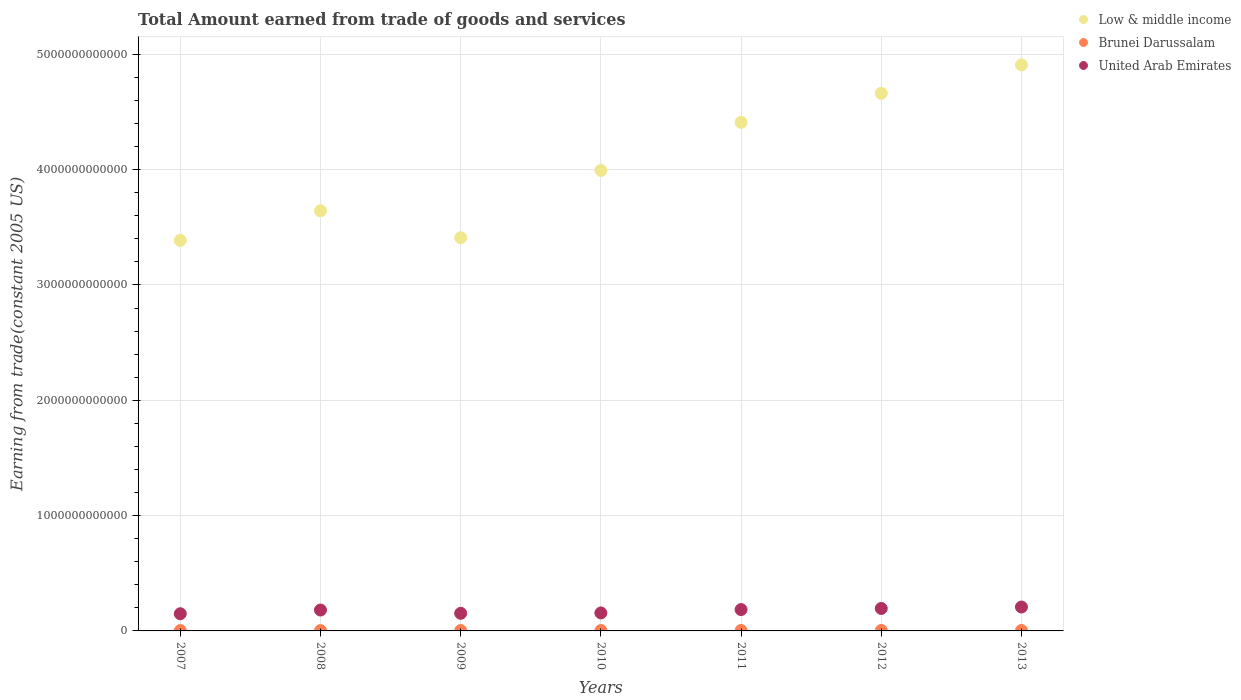How many different coloured dotlines are there?
Keep it short and to the point. 3. Is the number of dotlines equal to the number of legend labels?
Offer a terse response. Yes. What is the total amount earned by trading goods and services in United Arab Emirates in 2009?
Your answer should be very brief. 1.53e+11. Across all years, what is the maximum total amount earned by trading goods and services in United Arab Emirates?
Your response must be concise. 2.07e+11. Across all years, what is the minimum total amount earned by trading goods and services in Low & middle income?
Make the answer very short. 3.39e+12. In which year was the total amount earned by trading goods and services in United Arab Emirates maximum?
Offer a very short reply. 2013. In which year was the total amount earned by trading goods and services in Brunei Darussalam minimum?
Provide a short and direct response. 2007. What is the total total amount earned by trading goods and services in Brunei Darussalam in the graph?
Keep it short and to the point. 2.53e+1. What is the difference between the total amount earned by trading goods and services in Low & middle income in 2009 and that in 2011?
Keep it short and to the point. -1.00e+12. What is the difference between the total amount earned by trading goods and services in Brunei Darussalam in 2011 and the total amount earned by trading goods and services in United Arab Emirates in 2013?
Your answer should be compact. -2.04e+11. What is the average total amount earned by trading goods and services in Brunei Darussalam per year?
Your answer should be very brief. 3.62e+09. In the year 2008, what is the difference between the total amount earned by trading goods and services in Low & middle income and total amount earned by trading goods and services in Brunei Darussalam?
Provide a succinct answer. 3.64e+12. In how many years, is the total amount earned by trading goods and services in Brunei Darussalam greater than 800000000000 US$?
Your answer should be very brief. 0. What is the ratio of the total amount earned by trading goods and services in United Arab Emirates in 2009 to that in 2013?
Your answer should be very brief. 0.74. Is the total amount earned by trading goods and services in Brunei Darussalam in 2010 less than that in 2011?
Provide a succinct answer. Yes. What is the difference between the highest and the second highest total amount earned by trading goods and services in Low & middle income?
Keep it short and to the point. 2.47e+11. What is the difference between the highest and the lowest total amount earned by trading goods and services in United Arab Emirates?
Ensure brevity in your answer.  5.82e+1. In how many years, is the total amount earned by trading goods and services in United Arab Emirates greater than the average total amount earned by trading goods and services in United Arab Emirates taken over all years?
Give a very brief answer. 4. Is the sum of the total amount earned by trading goods and services in Low & middle income in 2007 and 2012 greater than the maximum total amount earned by trading goods and services in United Arab Emirates across all years?
Offer a terse response. Yes. Is it the case that in every year, the sum of the total amount earned by trading goods and services in Low & middle income and total amount earned by trading goods and services in Brunei Darussalam  is greater than the total amount earned by trading goods and services in United Arab Emirates?
Give a very brief answer. Yes. Is the total amount earned by trading goods and services in Low & middle income strictly greater than the total amount earned by trading goods and services in Brunei Darussalam over the years?
Your answer should be compact. Yes. Is the total amount earned by trading goods and services in Low & middle income strictly less than the total amount earned by trading goods and services in Brunei Darussalam over the years?
Your response must be concise. No. How many dotlines are there?
Your answer should be compact. 3. What is the difference between two consecutive major ticks on the Y-axis?
Offer a terse response. 1.00e+12. Does the graph contain grids?
Provide a short and direct response. Yes. Where does the legend appear in the graph?
Provide a succinct answer. Top right. How are the legend labels stacked?
Provide a succinct answer. Vertical. What is the title of the graph?
Provide a succinct answer. Total Amount earned from trade of goods and services. Does "Cyprus" appear as one of the legend labels in the graph?
Offer a terse response. No. What is the label or title of the X-axis?
Your answer should be very brief. Years. What is the label or title of the Y-axis?
Ensure brevity in your answer.  Earning from trade(constant 2005 US). What is the Earning from trade(constant 2005 US) of Low & middle income in 2007?
Provide a succinct answer. 3.39e+12. What is the Earning from trade(constant 2005 US) in Brunei Darussalam in 2007?
Ensure brevity in your answer.  3.07e+09. What is the Earning from trade(constant 2005 US) in United Arab Emirates in 2007?
Ensure brevity in your answer.  1.49e+11. What is the Earning from trade(constant 2005 US) of Low & middle income in 2008?
Provide a short and direct response. 3.64e+12. What is the Earning from trade(constant 2005 US) in Brunei Darussalam in 2008?
Your answer should be very brief. 3.40e+09. What is the Earning from trade(constant 2005 US) in United Arab Emirates in 2008?
Give a very brief answer. 1.81e+11. What is the Earning from trade(constant 2005 US) of Low & middle income in 2009?
Keep it short and to the point. 3.41e+12. What is the Earning from trade(constant 2005 US) in Brunei Darussalam in 2009?
Your answer should be very brief. 3.37e+09. What is the Earning from trade(constant 2005 US) of United Arab Emirates in 2009?
Your response must be concise. 1.53e+11. What is the Earning from trade(constant 2005 US) in Low & middle income in 2010?
Your response must be concise. 3.99e+12. What is the Earning from trade(constant 2005 US) of Brunei Darussalam in 2010?
Your answer should be compact. 3.37e+09. What is the Earning from trade(constant 2005 US) in United Arab Emirates in 2010?
Keep it short and to the point. 1.56e+11. What is the Earning from trade(constant 2005 US) in Low & middle income in 2011?
Your answer should be very brief. 4.41e+12. What is the Earning from trade(constant 2005 US) in Brunei Darussalam in 2011?
Provide a short and direct response. 3.75e+09. What is the Earning from trade(constant 2005 US) in United Arab Emirates in 2011?
Your answer should be compact. 1.85e+11. What is the Earning from trade(constant 2005 US) of Low & middle income in 2012?
Make the answer very short. 4.66e+12. What is the Earning from trade(constant 2005 US) in Brunei Darussalam in 2012?
Give a very brief answer. 4.23e+09. What is the Earning from trade(constant 2005 US) of United Arab Emirates in 2012?
Keep it short and to the point. 1.95e+11. What is the Earning from trade(constant 2005 US) in Low & middle income in 2013?
Your response must be concise. 4.91e+12. What is the Earning from trade(constant 2005 US) of Brunei Darussalam in 2013?
Ensure brevity in your answer.  4.16e+09. What is the Earning from trade(constant 2005 US) in United Arab Emirates in 2013?
Your answer should be compact. 2.07e+11. Across all years, what is the maximum Earning from trade(constant 2005 US) of Low & middle income?
Your answer should be very brief. 4.91e+12. Across all years, what is the maximum Earning from trade(constant 2005 US) of Brunei Darussalam?
Your answer should be very brief. 4.23e+09. Across all years, what is the maximum Earning from trade(constant 2005 US) of United Arab Emirates?
Provide a succinct answer. 2.07e+11. Across all years, what is the minimum Earning from trade(constant 2005 US) in Low & middle income?
Your response must be concise. 3.39e+12. Across all years, what is the minimum Earning from trade(constant 2005 US) in Brunei Darussalam?
Provide a succinct answer. 3.07e+09. Across all years, what is the minimum Earning from trade(constant 2005 US) of United Arab Emirates?
Offer a terse response. 1.49e+11. What is the total Earning from trade(constant 2005 US) of Low & middle income in the graph?
Provide a short and direct response. 2.84e+13. What is the total Earning from trade(constant 2005 US) in Brunei Darussalam in the graph?
Give a very brief answer. 2.53e+1. What is the total Earning from trade(constant 2005 US) of United Arab Emirates in the graph?
Provide a short and direct response. 1.23e+12. What is the difference between the Earning from trade(constant 2005 US) of Low & middle income in 2007 and that in 2008?
Your answer should be compact. -2.57e+11. What is the difference between the Earning from trade(constant 2005 US) of Brunei Darussalam in 2007 and that in 2008?
Your answer should be very brief. -3.36e+08. What is the difference between the Earning from trade(constant 2005 US) in United Arab Emirates in 2007 and that in 2008?
Provide a succinct answer. -3.19e+1. What is the difference between the Earning from trade(constant 2005 US) in Low & middle income in 2007 and that in 2009?
Offer a very short reply. -2.31e+1. What is the difference between the Earning from trade(constant 2005 US) in Brunei Darussalam in 2007 and that in 2009?
Your answer should be very brief. -3.09e+08. What is the difference between the Earning from trade(constant 2005 US) of United Arab Emirates in 2007 and that in 2009?
Provide a short and direct response. -3.57e+09. What is the difference between the Earning from trade(constant 2005 US) of Low & middle income in 2007 and that in 2010?
Ensure brevity in your answer.  -6.06e+11. What is the difference between the Earning from trade(constant 2005 US) of Brunei Darussalam in 2007 and that in 2010?
Make the answer very short. -3.00e+08. What is the difference between the Earning from trade(constant 2005 US) in United Arab Emirates in 2007 and that in 2010?
Offer a terse response. -6.81e+09. What is the difference between the Earning from trade(constant 2005 US) in Low & middle income in 2007 and that in 2011?
Offer a very short reply. -1.02e+12. What is the difference between the Earning from trade(constant 2005 US) of Brunei Darussalam in 2007 and that in 2011?
Your answer should be compact. -6.85e+08. What is the difference between the Earning from trade(constant 2005 US) in United Arab Emirates in 2007 and that in 2011?
Offer a terse response. -3.61e+1. What is the difference between the Earning from trade(constant 2005 US) of Low & middle income in 2007 and that in 2012?
Your answer should be very brief. -1.28e+12. What is the difference between the Earning from trade(constant 2005 US) of Brunei Darussalam in 2007 and that in 2012?
Provide a short and direct response. -1.16e+09. What is the difference between the Earning from trade(constant 2005 US) of United Arab Emirates in 2007 and that in 2012?
Provide a short and direct response. -4.56e+1. What is the difference between the Earning from trade(constant 2005 US) in Low & middle income in 2007 and that in 2013?
Your answer should be very brief. -1.52e+12. What is the difference between the Earning from trade(constant 2005 US) in Brunei Darussalam in 2007 and that in 2013?
Provide a succinct answer. -1.10e+09. What is the difference between the Earning from trade(constant 2005 US) in United Arab Emirates in 2007 and that in 2013?
Your answer should be compact. -5.82e+1. What is the difference between the Earning from trade(constant 2005 US) of Low & middle income in 2008 and that in 2009?
Give a very brief answer. 2.34e+11. What is the difference between the Earning from trade(constant 2005 US) of Brunei Darussalam in 2008 and that in 2009?
Offer a very short reply. 2.73e+07. What is the difference between the Earning from trade(constant 2005 US) in United Arab Emirates in 2008 and that in 2009?
Offer a terse response. 2.83e+1. What is the difference between the Earning from trade(constant 2005 US) of Low & middle income in 2008 and that in 2010?
Offer a terse response. -3.50e+11. What is the difference between the Earning from trade(constant 2005 US) in Brunei Darussalam in 2008 and that in 2010?
Your response must be concise. 3.63e+07. What is the difference between the Earning from trade(constant 2005 US) of United Arab Emirates in 2008 and that in 2010?
Your answer should be very brief. 2.51e+1. What is the difference between the Earning from trade(constant 2005 US) of Low & middle income in 2008 and that in 2011?
Ensure brevity in your answer.  -7.67e+11. What is the difference between the Earning from trade(constant 2005 US) in Brunei Darussalam in 2008 and that in 2011?
Give a very brief answer. -3.49e+08. What is the difference between the Earning from trade(constant 2005 US) in United Arab Emirates in 2008 and that in 2011?
Give a very brief answer. -4.16e+09. What is the difference between the Earning from trade(constant 2005 US) in Low & middle income in 2008 and that in 2012?
Provide a short and direct response. -1.02e+12. What is the difference between the Earning from trade(constant 2005 US) of Brunei Darussalam in 2008 and that in 2012?
Your answer should be compact. -8.27e+08. What is the difference between the Earning from trade(constant 2005 US) in United Arab Emirates in 2008 and that in 2012?
Keep it short and to the point. -1.37e+1. What is the difference between the Earning from trade(constant 2005 US) in Low & middle income in 2008 and that in 2013?
Provide a succinct answer. -1.27e+12. What is the difference between the Earning from trade(constant 2005 US) in Brunei Darussalam in 2008 and that in 2013?
Make the answer very short. -7.61e+08. What is the difference between the Earning from trade(constant 2005 US) in United Arab Emirates in 2008 and that in 2013?
Keep it short and to the point. -2.63e+1. What is the difference between the Earning from trade(constant 2005 US) in Low & middle income in 2009 and that in 2010?
Provide a short and direct response. -5.83e+11. What is the difference between the Earning from trade(constant 2005 US) of Brunei Darussalam in 2009 and that in 2010?
Your answer should be compact. 9.04e+06. What is the difference between the Earning from trade(constant 2005 US) in United Arab Emirates in 2009 and that in 2010?
Offer a very short reply. -3.24e+09. What is the difference between the Earning from trade(constant 2005 US) in Low & middle income in 2009 and that in 2011?
Your answer should be compact. -1.00e+12. What is the difference between the Earning from trade(constant 2005 US) of Brunei Darussalam in 2009 and that in 2011?
Your answer should be compact. -3.76e+08. What is the difference between the Earning from trade(constant 2005 US) of United Arab Emirates in 2009 and that in 2011?
Provide a succinct answer. -3.25e+1. What is the difference between the Earning from trade(constant 2005 US) in Low & middle income in 2009 and that in 2012?
Provide a succinct answer. -1.25e+12. What is the difference between the Earning from trade(constant 2005 US) in Brunei Darussalam in 2009 and that in 2012?
Offer a terse response. -8.54e+08. What is the difference between the Earning from trade(constant 2005 US) in United Arab Emirates in 2009 and that in 2012?
Your response must be concise. -4.21e+1. What is the difference between the Earning from trade(constant 2005 US) in Low & middle income in 2009 and that in 2013?
Your response must be concise. -1.50e+12. What is the difference between the Earning from trade(constant 2005 US) of Brunei Darussalam in 2009 and that in 2013?
Keep it short and to the point. -7.89e+08. What is the difference between the Earning from trade(constant 2005 US) in United Arab Emirates in 2009 and that in 2013?
Ensure brevity in your answer.  -5.47e+1. What is the difference between the Earning from trade(constant 2005 US) of Low & middle income in 2010 and that in 2011?
Offer a terse response. -4.17e+11. What is the difference between the Earning from trade(constant 2005 US) in Brunei Darussalam in 2010 and that in 2011?
Offer a terse response. -3.85e+08. What is the difference between the Earning from trade(constant 2005 US) in United Arab Emirates in 2010 and that in 2011?
Make the answer very short. -2.93e+1. What is the difference between the Earning from trade(constant 2005 US) of Low & middle income in 2010 and that in 2012?
Your answer should be compact. -6.69e+11. What is the difference between the Earning from trade(constant 2005 US) in Brunei Darussalam in 2010 and that in 2012?
Ensure brevity in your answer.  -8.63e+08. What is the difference between the Earning from trade(constant 2005 US) of United Arab Emirates in 2010 and that in 2012?
Offer a terse response. -3.88e+1. What is the difference between the Earning from trade(constant 2005 US) of Low & middle income in 2010 and that in 2013?
Offer a terse response. -9.16e+11. What is the difference between the Earning from trade(constant 2005 US) of Brunei Darussalam in 2010 and that in 2013?
Your answer should be compact. -7.98e+08. What is the difference between the Earning from trade(constant 2005 US) of United Arab Emirates in 2010 and that in 2013?
Provide a succinct answer. -5.14e+1. What is the difference between the Earning from trade(constant 2005 US) in Low & middle income in 2011 and that in 2012?
Give a very brief answer. -2.51e+11. What is the difference between the Earning from trade(constant 2005 US) in Brunei Darussalam in 2011 and that in 2012?
Your answer should be compact. -4.78e+08. What is the difference between the Earning from trade(constant 2005 US) in United Arab Emirates in 2011 and that in 2012?
Make the answer very short. -9.55e+09. What is the difference between the Earning from trade(constant 2005 US) of Low & middle income in 2011 and that in 2013?
Provide a short and direct response. -4.99e+11. What is the difference between the Earning from trade(constant 2005 US) in Brunei Darussalam in 2011 and that in 2013?
Your answer should be very brief. -4.13e+08. What is the difference between the Earning from trade(constant 2005 US) of United Arab Emirates in 2011 and that in 2013?
Make the answer very short. -2.22e+1. What is the difference between the Earning from trade(constant 2005 US) of Low & middle income in 2012 and that in 2013?
Your answer should be very brief. -2.47e+11. What is the difference between the Earning from trade(constant 2005 US) of Brunei Darussalam in 2012 and that in 2013?
Ensure brevity in your answer.  6.52e+07. What is the difference between the Earning from trade(constant 2005 US) of United Arab Emirates in 2012 and that in 2013?
Give a very brief answer. -1.26e+1. What is the difference between the Earning from trade(constant 2005 US) in Low & middle income in 2007 and the Earning from trade(constant 2005 US) in Brunei Darussalam in 2008?
Offer a very short reply. 3.38e+12. What is the difference between the Earning from trade(constant 2005 US) in Low & middle income in 2007 and the Earning from trade(constant 2005 US) in United Arab Emirates in 2008?
Make the answer very short. 3.21e+12. What is the difference between the Earning from trade(constant 2005 US) in Brunei Darussalam in 2007 and the Earning from trade(constant 2005 US) in United Arab Emirates in 2008?
Provide a succinct answer. -1.78e+11. What is the difference between the Earning from trade(constant 2005 US) in Low & middle income in 2007 and the Earning from trade(constant 2005 US) in Brunei Darussalam in 2009?
Ensure brevity in your answer.  3.38e+12. What is the difference between the Earning from trade(constant 2005 US) of Low & middle income in 2007 and the Earning from trade(constant 2005 US) of United Arab Emirates in 2009?
Provide a short and direct response. 3.23e+12. What is the difference between the Earning from trade(constant 2005 US) in Brunei Darussalam in 2007 and the Earning from trade(constant 2005 US) in United Arab Emirates in 2009?
Offer a very short reply. -1.50e+11. What is the difference between the Earning from trade(constant 2005 US) of Low & middle income in 2007 and the Earning from trade(constant 2005 US) of Brunei Darussalam in 2010?
Provide a short and direct response. 3.38e+12. What is the difference between the Earning from trade(constant 2005 US) in Low & middle income in 2007 and the Earning from trade(constant 2005 US) in United Arab Emirates in 2010?
Provide a short and direct response. 3.23e+12. What is the difference between the Earning from trade(constant 2005 US) in Brunei Darussalam in 2007 and the Earning from trade(constant 2005 US) in United Arab Emirates in 2010?
Make the answer very short. -1.53e+11. What is the difference between the Earning from trade(constant 2005 US) in Low & middle income in 2007 and the Earning from trade(constant 2005 US) in Brunei Darussalam in 2011?
Your response must be concise. 3.38e+12. What is the difference between the Earning from trade(constant 2005 US) in Low & middle income in 2007 and the Earning from trade(constant 2005 US) in United Arab Emirates in 2011?
Make the answer very short. 3.20e+12. What is the difference between the Earning from trade(constant 2005 US) in Brunei Darussalam in 2007 and the Earning from trade(constant 2005 US) in United Arab Emirates in 2011?
Keep it short and to the point. -1.82e+11. What is the difference between the Earning from trade(constant 2005 US) of Low & middle income in 2007 and the Earning from trade(constant 2005 US) of Brunei Darussalam in 2012?
Provide a short and direct response. 3.38e+12. What is the difference between the Earning from trade(constant 2005 US) of Low & middle income in 2007 and the Earning from trade(constant 2005 US) of United Arab Emirates in 2012?
Keep it short and to the point. 3.19e+12. What is the difference between the Earning from trade(constant 2005 US) of Brunei Darussalam in 2007 and the Earning from trade(constant 2005 US) of United Arab Emirates in 2012?
Your answer should be very brief. -1.92e+11. What is the difference between the Earning from trade(constant 2005 US) of Low & middle income in 2007 and the Earning from trade(constant 2005 US) of Brunei Darussalam in 2013?
Ensure brevity in your answer.  3.38e+12. What is the difference between the Earning from trade(constant 2005 US) of Low & middle income in 2007 and the Earning from trade(constant 2005 US) of United Arab Emirates in 2013?
Provide a succinct answer. 3.18e+12. What is the difference between the Earning from trade(constant 2005 US) in Brunei Darussalam in 2007 and the Earning from trade(constant 2005 US) in United Arab Emirates in 2013?
Your response must be concise. -2.04e+11. What is the difference between the Earning from trade(constant 2005 US) of Low & middle income in 2008 and the Earning from trade(constant 2005 US) of Brunei Darussalam in 2009?
Offer a terse response. 3.64e+12. What is the difference between the Earning from trade(constant 2005 US) of Low & middle income in 2008 and the Earning from trade(constant 2005 US) of United Arab Emirates in 2009?
Offer a terse response. 3.49e+12. What is the difference between the Earning from trade(constant 2005 US) in Brunei Darussalam in 2008 and the Earning from trade(constant 2005 US) in United Arab Emirates in 2009?
Your answer should be compact. -1.49e+11. What is the difference between the Earning from trade(constant 2005 US) in Low & middle income in 2008 and the Earning from trade(constant 2005 US) in Brunei Darussalam in 2010?
Keep it short and to the point. 3.64e+12. What is the difference between the Earning from trade(constant 2005 US) in Low & middle income in 2008 and the Earning from trade(constant 2005 US) in United Arab Emirates in 2010?
Your answer should be very brief. 3.49e+12. What is the difference between the Earning from trade(constant 2005 US) in Brunei Darussalam in 2008 and the Earning from trade(constant 2005 US) in United Arab Emirates in 2010?
Provide a succinct answer. -1.53e+11. What is the difference between the Earning from trade(constant 2005 US) of Low & middle income in 2008 and the Earning from trade(constant 2005 US) of Brunei Darussalam in 2011?
Offer a terse response. 3.64e+12. What is the difference between the Earning from trade(constant 2005 US) in Low & middle income in 2008 and the Earning from trade(constant 2005 US) in United Arab Emirates in 2011?
Make the answer very short. 3.46e+12. What is the difference between the Earning from trade(constant 2005 US) of Brunei Darussalam in 2008 and the Earning from trade(constant 2005 US) of United Arab Emirates in 2011?
Offer a very short reply. -1.82e+11. What is the difference between the Earning from trade(constant 2005 US) in Low & middle income in 2008 and the Earning from trade(constant 2005 US) in Brunei Darussalam in 2012?
Your answer should be very brief. 3.64e+12. What is the difference between the Earning from trade(constant 2005 US) in Low & middle income in 2008 and the Earning from trade(constant 2005 US) in United Arab Emirates in 2012?
Ensure brevity in your answer.  3.45e+12. What is the difference between the Earning from trade(constant 2005 US) of Brunei Darussalam in 2008 and the Earning from trade(constant 2005 US) of United Arab Emirates in 2012?
Your answer should be very brief. -1.91e+11. What is the difference between the Earning from trade(constant 2005 US) in Low & middle income in 2008 and the Earning from trade(constant 2005 US) in Brunei Darussalam in 2013?
Your answer should be very brief. 3.64e+12. What is the difference between the Earning from trade(constant 2005 US) of Low & middle income in 2008 and the Earning from trade(constant 2005 US) of United Arab Emirates in 2013?
Give a very brief answer. 3.44e+12. What is the difference between the Earning from trade(constant 2005 US) of Brunei Darussalam in 2008 and the Earning from trade(constant 2005 US) of United Arab Emirates in 2013?
Your response must be concise. -2.04e+11. What is the difference between the Earning from trade(constant 2005 US) of Low & middle income in 2009 and the Earning from trade(constant 2005 US) of Brunei Darussalam in 2010?
Provide a short and direct response. 3.41e+12. What is the difference between the Earning from trade(constant 2005 US) in Low & middle income in 2009 and the Earning from trade(constant 2005 US) in United Arab Emirates in 2010?
Keep it short and to the point. 3.25e+12. What is the difference between the Earning from trade(constant 2005 US) of Brunei Darussalam in 2009 and the Earning from trade(constant 2005 US) of United Arab Emirates in 2010?
Offer a very short reply. -1.53e+11. What is the difference between the Earning from trade(constant 2005 US) of Low & middle income in 2009 and the Earning from trade(constant 2005 US) of Brunei Darussalam in 2011?
Your response must be concise. 3.41e+12. What is the difference between the Earning from trade(constant 2005 US) of Low & middle income in 2009 and the Earning from trade(constant 2005 US) of United Arab Emirates in 2011?
Your answer should be compact. 3.22e+12. What is the difference between the Earning from trade(constant 2005 US) of Brunei Darussalam in 2009 and the Earning from trade(constant 2005 US) of United Arab Emirates in 2011?
Offer a terse response. -1.82e+11. What is the difference between the Earning from trade(constant 2005 US) of Low & middle income in 2009 and the Earning from trade(constant 2005 US) of Brunei Darussalam in 2012?
Provide a succinct answer. 3.41e+12. What is the difference between the Earning from trade(constant 2005 US) in Low & middle income in 2009 and the Earning from trade(constant 2005 US) in United Arab Emirates in 2012?
Offer a terse response. 3.22e+12. What is the difference between the Earning from trade(constant 2005 US) in Brunei Darussalam in 2009 and the Earning from trade(constant 2005 US) in United Arab Emirates in 2012?
Your answer should be very brief. -1.91e+11. What is the difference between the Earning from trade(constant 2005 US) of Low & middle income in 2009 and the Earning from trade(constant 2005 US) of Brunei Darussalam in 2013?
Your answer should be very brief. 3.41e+12. What is the difference between the Earning from trade(constant 2005 US) of Low & middle income in 2009 and the Earning from trade(constant 2005 US) of United Arab Emirates in 2013?
Give a very brief answer. 3.20e+12. What is the difference between the Earning from trade(constant 2005 US) of Brunei Darussalam in 2009 and the Earning from trade(constant 2005 US) of United Arab Emirates in 2013?
Make the answer very short. -2.04e+11. What is the difference between the Earning from trade(constant 2005 US) of Low & middle income in 2010 and the Earning from trade(constant 2005 US) of Brunei Darussalam in 2011?
Your answer should be very brief. 3.99e+12. What is the difference between the Earning from trade(constant 2005 US) of Low & middle income in 2010 and the Earning from trade(constant 2005 US) of United Arab Emirates in 2011?
Give a very brief answer. 3.81e+12. What is the difference between the Earning from trade(constant 2005 US) of Brunei Darussalam in 2010 and the Earning from trade(constant 2005 US) of United Arab Emirates in 2011?
Your answer should be very brief. -1.82e+11. What is the difference between the Earning from trade(constant 2005 US) in Low & middle income in 2010 and the Earning from trade(constant 2005 US) in Brunei Darussalam in 2012?
Your answer should be compact. 3.99e+12. What is the difference between the Earning from trade(constant 2005 US) of Low & middle income in 2010 and the Earning from trade(constant 2005 US) of United Arab Emirates in 2012?
Provide a short and direct response. 3.80e+12. What is the difference between the Earning from trade(constant 2005 US) in Brunei Darussalam in 2010 and the Earning from trade(constant 2005 US) in United Arab Emirates in 2012?
Your answer should be very brief. -1.91e+11. What is the difference between the Earning from trade(constant 2005 US) of Low & middle income in 2010 and the Earning from trade(constant 2005 US) of Brunei Darussalam in 2013?
Your answer should be compact. 3.99e+12. What is the difference between the Earning from trade(constant 2005 US) in Low & middle income in 2010 and the Earning from trade(constant 2005 US) in United Arab Emirates in 2013?
Ensure brevity in your answer.  3.79e+12. What is the difference between the Earning from trade(constant 2005 US) of Brunei Darussalam in 2010 and the Earning from trade(constant 2005 US) of United Arab Emirates in 2013?
Ensure brevity in your answer.  -2.04e+11. What is the difference between the Earning from trade(constant 2005 US) in Low & middle income in 2011 and the Earning from trade(constant 2005 US) in Brunei Darussalam in 2012?
Your answer should be compact. 4.41e+12. What is the difference between the Earning from trade(constant 2005 US) of Low & middle income in 2011 and the Earning from trade(constant 2005 US) of United Arab Emirates in 2012?
Provide a short and direct response. 4.22e+12. What is the difference between the Earning from trade(constant 2005 US) of Brunei Darussalam in 2011 and the Earning from trade(constant 2005 US) of United Arab Emirates in 2012?
Your answer should be compact. -1.91e+11. What is the difference between the Earning from trade(constant 2005 US) of Low & middle income in 2011 and the Earning from trade(constant 2005 US) of Brunei Darussalam in 2013?
Provide a succinct answer. 4.41e+12. What is the difference between the Earning from trade(constant 2005 US) in Low & middle income in 2011 and the Earning from trade(constant 2005 US) in United Arab Emirates in 2013?
Keep it short and to the point. 4.20e+12. What is the difference between the Earning from trade(constant 2005 US) in Brunei Darussalam in 2011 and the Earning from trade(constant 2005 US) in United Arab Emirates in 2013?
Offer a very short reply. -2.04e+11. What is the difference between the Earning from trade(constant 2005 US) in Low & middle income in 2012 and the Earning from trade(constant 2005 US) in Brunei Darussalam in 2013?
Make the answer very short. 4.66e+12. What is the difference between the Earning from trade(constant 2005 US) of Low & middle income in 2012 and the Earning from trade(constant 2005 US) of United Arab Emirates in 2013?
Ensure brevity in your answer.  4.45e+12. What is the difference between the Earning from trade(constant 2005 US) of Brunei Darussalam in 2012 and the Earning from trade(constant 2005 US) of United Arab Emirates in 2013?
Ensure brevity in your answer.  -2.03e+11. What is the average Earning from trade(constant 2005 US) in Low & middle income per year?
Make the answer very short. 4.06e+12. What is the average Earning from trade(constant 2005 US) of Brunei Darussalam per year?
Offer a terse response. 3.62e+09. What is the average Earning from trade(constant 2005 US) of United Arab Emirates per year?
Offer a very short reply. 1.75e+11. In the year 2007, what is the difference between the Earning from trade(constant 2005 US) of Low & middle income and Earning from trade(constant 2005 US) of Brunei Darussalam?
Ensure brevity in your answer.  3.38e+12. In the year 2007, what is the difference between the Earning from trade(constant 2005 US) in Low & middle income and Earning from trade(constant 2005 US) in United Arab Emirates?
Offer a terse response. 3.24e+12. In the year 2007, what is the difference between the Earning from trade(constant 2005 US) of Brunei Darussalam and Earning from trade(constant 2005 US) of United Arab Emirates?
Provide a short and direct response. -1.46e+11. In the year 2008, what is the difference between the Earning from trade(constant 2005 US) in Low & middle income and Earning from trade(constant 2005 US) in Brunei Darussalam?
Provide a short and direct response. 3.64e+12. In the year 2008, what is the difference between the Earning from trade(constant 2005 US) of Low & middle income and Earning from trade(constant 2005 US) of United Arab Emirates?
Make the answer very short. 3.46e+12. In the year 2008, what is the difference between the Earning from trade(constant 2005 US) of Brunei Darussalam and Earning from trade(constant 2005 US) of United Arab Emirates?
Your answer should be very brief. -1.78e+11. In the year 2009, what is the difference between the Earning from trade(constant 2005 US) of Low & middle income and Earning from trade(constant 2005 US) of Brunei Darussalam?
Your response must be concise. 3.41e+12. In the year 2009, what is the difference between the Earning from trade(constant 2005 US) of Low & middle income and Earning from trade(constant 2005 US) of United Arab Emirates?
Ensure brevity in your answer.  3.26e+12. In the year 2009, what is the difference between the Earning from trade(constant 2005 US) of Brunei Darussalam and Earning from trade(constant 2005 US) of United Arab Emirates?
Offer a terse response. -1.49e+11. In the year 2010, what is the difference between the Earning from trade(constant 2005 US) in Low & middle income and Earning from trade(constant 2005 US) in Brunei Darussalam?
Give a very brief answer. 3.99e+12. In the year 2010, what is the difference between the Earning from trade(constant 2005 US) in Low & middle income and Earning from trade(constant 2005 US) in United Arab Emirates?
Provide a succinct answer. 3.84e+12. In the year 2010, what is the difference between the Earning from trade(constant 2005 US) in Brunei Darussalam and Earning from trade(constant 2005 US) in United Arab Emirates?
Give a very brief answer. -1.53e+11. In the year 2011, what is the difference between the Earning from trade(constant 2005 US) in Low & middle income and Earning from trade(constant 2005 US) in Brunei Darussalam?
Keep it short and to the point. 4.41e+12. In the year 2011, what is the difference between the Earning from trade(constant 2005 US) of Low & middle income and Earning from trade(constant 2005 US) of United Arab Emirates?
Give a very brief answer. 4.23e+12. In the year 2011, what is the difference between the Earning from trade(constant 2005 US) in Brunei Darussalam and Earning from trade(constant 2005 US) in United Arab Emirates?
Keep it short and to the point. -1.82e+11. In the year 2012, what is the difference between the Earning from trade(constant 2005 US) of Low & middle income and Earning from trade(constant 2005 US) of Brunei Darussalam?
Give a very brief answer. 4.66e+12. In the year 2012, what is the difference between the Earning from trade(constant 2005 US) in Low & middle income and Earning from trade(constant 2005 US) in United Arab Emirates?
Make the answer very short. 4.47e+12. In the year 2012, what is the difference between the Earning from trade(constant 2005 US) of Brunei Darussalam and Earning from trade(constant 2005 US) of United Arab Emirates?
Offer a very short reply. -1.91e+11. In the year 2013, what is the difference between the Earning from trade(constant 2005 US) of Low & middle income and Earning from trade(constant 2005 US) of Brunei Darussalam?
Give a very brief answer. 4.90e+12. In the year 2013, what is the difference between the Earning from trade(constant 2005 US) of Low & middle income and Earning from trade(constant 2005 US) of United Arab Emirates?
Make the answer very short. 4.70e+12. In the year 2013, what is the difference between the Earning from trade(constant 2005 US) in Brunei Darussalam and Earning from trade(constant 2005 US) in United Arab Emirates?
Offer a very short reply. -2.03e+11. What is the ratio of the Earning from trade(constant 2005 US) in Low & middle income in 2007 to that in 2008?
Your response must be concise. 0.93. What is the ratio of the Earning from trade(constant 2005 US) of Brunei Darussalam in 2007 to that in 2008?
Your answer should be very brief. 0.9. What is the ratio of the Earning from trade(constant 2005 US) of United Arab Emirates in 2007 to that in 2008?
Provide a short and direct response. 0.82. What is the ratio of the Earning from trade(constant 2005 US) of Low & middle income in 2007 to that in 2009?
Ensure brevity in your answer.  0.99. What is the ratio of the Earning from trade(constant 2005 US) in Brunei Darussalam in 2007 to that in 2009?
Provide a short and direct response. 0.91. What is the ratio of the Earning from trade(constant 2005 US) of United Arab Emirates in 2007 to that in 2009?
Provide a short and direct response. 0.98. What is the ratio of the Earning from trade(constant 2005 US) of Low & middle income in 2007 to that in 2010?
Your answer should be very brief. 0.85. What is the ratio of the Earning from trade(constant 2005 US) of Brunei Darussalam in 2007 to that in 2010?
Provide a succinct answer. 0.91. What is the ratio of the Earning from trade(constant 2005 US) of United Arab Emirates in 2007 to that in 2010?
Offer a terse response. 0.96. What is the ratio of the Earning from trade(constant 2005 US) of Low & middle income in 2007 to that in 2011?
Your answer should be very brief. 0.77. What is the ratio of the Earning from trade(constant 2005 US) of Brunei Darussalam in 2007 to that in 2011?
Offer a terse response. 0.82. What is the ratio of the Earning from trade(constant 2005 US) of United Arab Emirates in 2007 to that in 2011?
Make the answer very short. 0.81. What is the ratio of the Earning from trade(constant 2005 US) in Low & middle income in 2007 to that in 2012?
Ensure brevity in your answer.  0.73. What is the ratio of the Earning from trade(constant 2005 US) in Brunei Darussalam in 2007 to that in 2012?
Give a very brief answer. 0.72. What is the ratio of the Earning from trade(constant 2005 US) of United Arab Emirates in 2007 to that in 2012?
Give a very brief answer. 0.77. What is the ratio of the Earning from trade(constant 2005 US) in Low & middle income in 2007 to that in 2013?
Offer a terse response. 0.69. What is the ratio of the Earning from trade(constant 2005 US) of Brunei Darussalam in 2007 to that in 2013?
Your response must be concise. 0.74. What is the ratio of the Earning from trade(constant 2005 US) in United Arab Emirates in 2007 to that in 2013?
Your response must be concise. 0.72. What is the ratio of the Earning from trade(constant 2005 US) in Low & middle income in 2008 to that in 2009?
Your response must be concise. 1.07. What is the ratio of the Earning from trade(constant 2005 US) in Brunei Darussalam in 2008 to that in 2009?
Offer a terse response. 1.01. What is the ratio of the Earning from trade(constant 2005 US) of United Arab Emirates in 2008 to that in 2009?
Make the answer very short. 1.19. What is the ratio of the Earning from trade(constant 2005 US) of Low & middle income in 2008 to that in 2010?
Keep it short and to the point. 0.91. What is the ratio of the Earning from trade(constant 2005 US) of Brunei Darussalam in 2008 to that in 2010?
Your answer should be compact. 1.01. What is the ratio of the Earning from trade(constant 2005 US) of United Arab Emirates in 2008 to that in 2010?
Offer a terse response. 1.16. What is the ratio of the Earning from trade(constant 2005 US) of Low & middle income in 2008 to that in 2011?
Your answer should be compact. 0.83. What is the ratio of the Earning from trade(constant 2005 US) in Brunei Darussalam in 2008 to that in 2011?
Keep it short and to the point. 0.91. What is the ratio of the Earning from trade(constant 2005 US) in United Arab Emirates in 2008 to that in 2011?
Keep it short and to the point. 0.98. What is the ratio of the Earning from trade(constant 2005 US) of Low & middle income in 2008 to that in 2012?
Provide a succinct answer. 0.78. What is the ratio of the Earning from trade(constant 2005 US) in Brunei Darussalam in 2008 to that in 2012?
Provide a short and direct response. 0.8. What is the ratio of the Earning from trade(constant 2005 US) of United Arab Emirates in 2008 to that in 2012?
Your response must be concise. 0.93. What is the ratio of the Earning from trade(constant 2005 US) in Low & middle income in 2008 to that in 2013?
Your response must be concise. 0.74. What is the ratio of the Earning from trade(constant 2005 US) in Brunei Darussalam in 2008 to that in 2013?
Make the answer very short. 0.82. What is the ratio of the Earning from trade(constant 2005 US) in United Arab Emirates in 2008 to that in 2013?
Ensure brevity in your answer.  0.87. What is the ratio of the Earning from trade(constant 2005 US) of Low & middle income in 2009 to that in 2010?
Provide a short and direct response. 0.85. What is the ratio of the Earning from trade(constant 2005 US) of Brunei Darussalam in 2009 to that in 2010?
Give a very brief answer. 1. What is the ratio of the Earning from trade(constant 2005 US) of United Arab Emirates in 2009 to that in 2010?
Ensure brevity in your answer.  0.98. What is the ratio of the Earning from trade(constant 2005 US) of Low & middle income in 2009 to that in 2011?
Give a very brief answer. 0.77. What is the ratio of the Earning from trade(constant 2005 US) in Brunei Darussalam in 2009 to that in 2011?
Provide a succinct answer. 0.9. What is the ratio of the Earning from trade(constant 2005 US) of United Arab Emirates in 2009 to that in 2011?
Make the answer very short. 0.82. What is the ratio of the Earning from trade(constant 2005 US) in Low & middle income in 2009 to that in 2012?
Give a very brief answer. 0.73. What is the ratio of the Earning from trade(constant 2005 US) in Brunei Darussalam in 2009 to that in 2012?
Provide a succinct answer. 0.8. What is the ratio of the Earning from trade(constant 2005 US) in United Arab Emirates in 2009 to that in 2012?
Your answer should be very brief. 0.78. What is the ratio of the Earning from trade(constant 2005 US) in Low & middle income in 2009 to that in 2013?
Keep it short and to the point. 0.69. What is the ratio of the Earning from trade(constant 2005 US) of Brunei Darussalam in 2009 to that in 2013?
Provide a succinct answer. 0.81. What is the ratio of the Earning from trade(constant 2005 US) of United Arab Emirates in 2009 to that in 2013?
Ensure brevity in your answer.  0.74. What is the ratio of the Earning from trade(constant 2005 US) in Low & middle income in 2010 to that in 2011?
Provide a succinct answer. 0.91. What is the ratio of the Earning from trade(constant 2005 US) in Brunei Darussalam in 2010 to that in 2011?
Make the answer very short. 0.9. What is the ratio of the Earning from trade(constant 2005 US) in United Arab Emirates in 2010 to that in 2011?
Your response must be concise. 0.84. What is the ratio of the Earning from trade(constant 2005 US) of Low & middle income in 2010 to that in 2012?
Your response must be concise. 0.86. What is the ratio of the Earning from trade(constant 2005 US) of Brunei Darussalam in 2010 to that in 2012?
Offer a terse response. 0.8. What is the ratio of the Earning from trade(constant 2005 US) of United Arab Emirates in 2010 to that in 2012?
Make the answer very short. 0.8. What is the ratio of the Earning from trade(constant 2005 US) of Low & middle income in 2010 to that in 2013?
Make the answer very short. 0.81. What is the ratio of the Earning from trade(constant 2005 US) in Brunei Darussalam in 2010 to that in 2013?
Provide a succinct answer. 0.81. What is the ratio of the Earning from trade(constant 2005 US) of United Arab Emirates in 2010 to that in 2013?
Your answer should be very brief. 0.75. What is the ratio of the Earning from trade(constant 2005 US) of Low & middle income in 2011 to that in 2012?
Make the answer very short. 0.95. What is the ratio of the Earning from trade(constant 2005 US) of Brunei Darussalam in 2011 to that in 2012?
Make the answer very short. 0.89. What is the ratio of the Earning from trade(constant 2005 US) in United Arab Emirates in 2011 to that in 2012?
Ensure brevity in your answer.  0.95. What is the ratio of the Earning from trade(constant 2005 US) in Low & middle income in 2011 to that in 2013?
Make the answer very short. 0.9. What is the ratio of the Earning from trade(constant 2005 US) in Brunei Darussalam in 2011 to that in 2013?
Your answer should be compact. 0.9. What is the ratio of the Earning from trade(constant 2005 US) in United Arab Emirates in 2011 to that in 2013?
Provide a succinct answer. 0.89. What is the ratio of the Earning from trade(constant 2005 US) in Low & middle income in 2012 to that in 2013?
Offer a terse response. 0.95. What is the ratio of the Earning from trade(constant 2005 US) of Brunei Darussalam in 2012 to that in 2013?
Your answer should be compact. 1.02. What is the ratio of the Earning from trade(constant 2005 US) of United Arab Emirates in 2012 to that in 2013?
Make the answer very short. 0.94. What is the difference between the highest and the second highest Earning from trade(constant 2005 US) of Low & middle income?
Offer a terse response. 2.47e+11. What is the difference between the highest and the second highest Earning from trade(constant 2005 US) of Brunei Darussalam?
Keep it short and to the point. 6.52e+07. What is the difference between the highest and the second highest Earning from trade(constant 2005 US) of United Arab Emirates?
Make the answer very short. 1.26e+1. What is the difference between the highest and the lowest Earning from trade(constant 2005 US) of Low & middle income?
Your answer should be compact. 1.52e+12. What is the difference between the highest and the lowest Earning from trade(constant 2005 US) of Brunei Darussalam?
Give a very brief answer. 1.16e+09. What is the difference between the highest and the lowest Earning from trade(constant 2005 US) in United Arab Emirates?
Your answer should be very brief. 5.82e+1. 